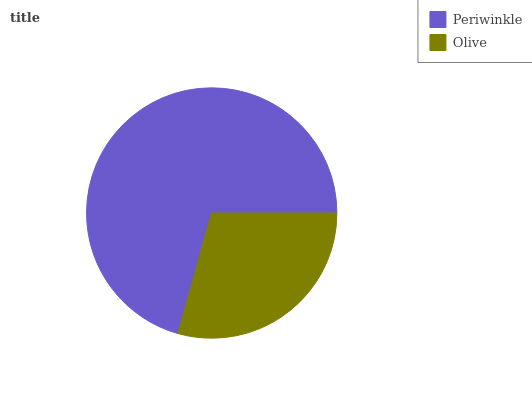Is Olive the minimum?
Answer yes or no. Yes. Is Periwinkle the maximum?
Answer yes or no. Yes. Is Olive the maximum?
Answer yes or no. No. Is Periwinkle greater than Olive?
Answer yes or no. Yes. Is Olive less than Periwinkle?
Answer yes or no. Yes. Is Olive greater than Periwinkle?
Answer yes or no. No. Is Periwinkle less than Olive?
Answer yes or no. No. Is Periwinkle the high median?
Answer yes or no. Yes. Is Olive the low median?
Answer yes or no. Yes. Is Olive the high median?
Answer yes or no. No. Is Periwinkle the low median?
Answer yes or no. No. 